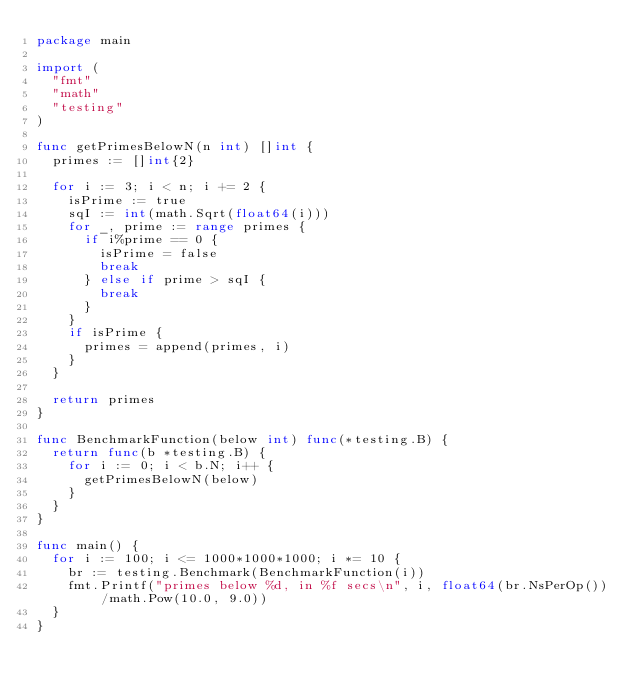<code> <loc_0><loc_0><loc_500><loc_500><_Go_>package main

import (
	"fmt"
	"math"
	"testing"
)

func getPrimesBelowN(n int) []int {
	primes := []int{2}

	for i := 3; i < n; i += 2 {
		isPrime := true
		sqI := int(math.Sqrt(float64(i)))
		for _, prime := range primes {
			if i%prime == 0 {
				isPrime = false
				break
			} else if prime > sqI {
				break
			}
		}
		if isPrime {
			primes = append(primes, i)
		}
	}

	return primes
}

func BenchmarkFunction(below int) func(*testing.B) {
	return func(b *testing.B) {
		for i := 0; i < b.N; i++ {
			getPrimesBelowN(below)
		}
	}
}

func main() {
	for i := 100; i <= 1000*1000*1000; i *= 10 {
		br := testing.Benchmark(BenchmarkFunction(i))
		fmt.Printf("primes below %d, in %f secs\n", i, float64(br.NsPerOp())/math.Pow(10.0, 9.0))
	}
}
</code> 